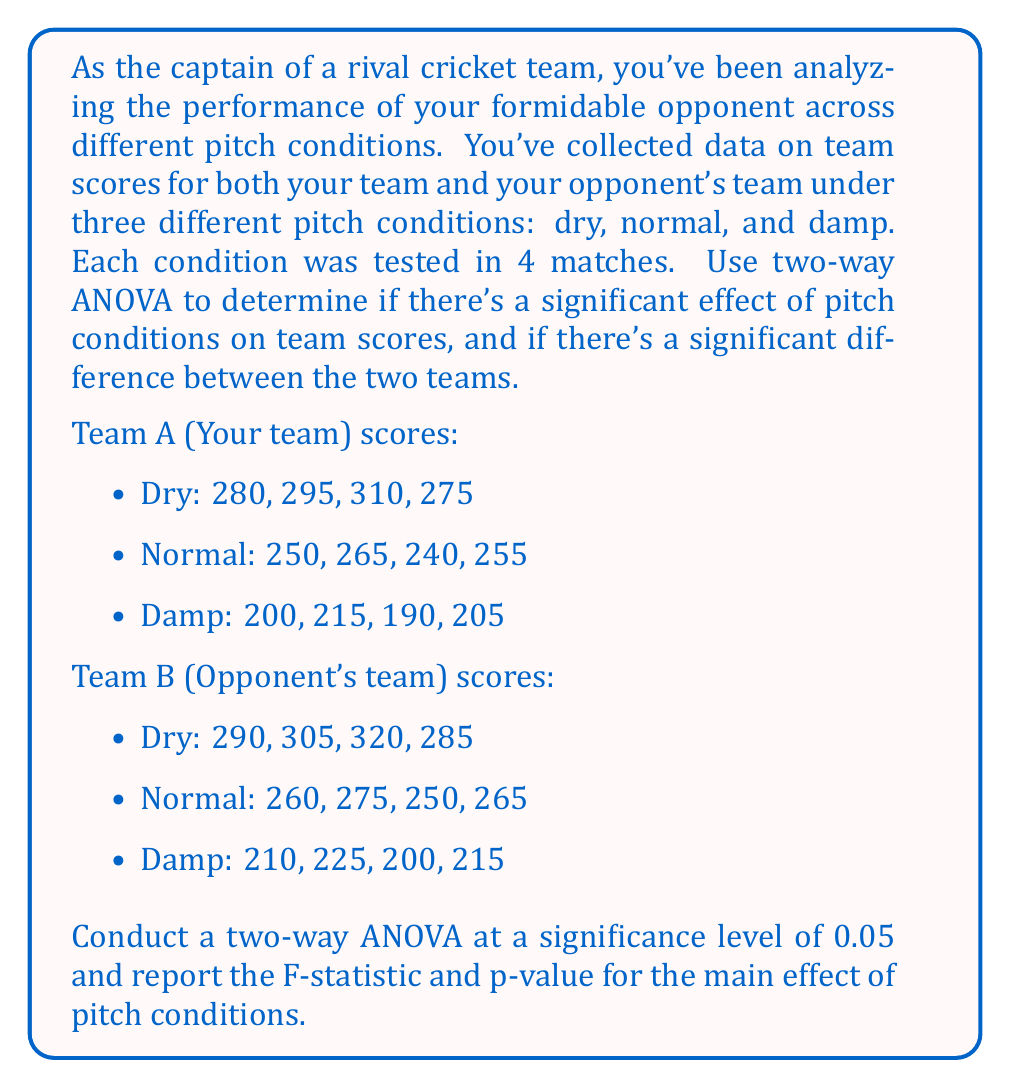Help me with this question. To conduct a two-way ANOVA, we'll follow these steps:

1. Calculate the total sum of squares (SST), sum of squares for pitch conditions (SSA), sum of squares for teams (SSB), sum of squares for interaction (SSAB), and sum of squares for error (SSE).

2. Calculate the degrees of freedom for each source of variation.

3. Calculate the mean squares for each source of variation.

4. Calculate the F-statistics and p-values.

Let's begin:

1. Calculating sums of squares:

SST = $\sum_{i=1}^{a}\sum_{j=1}^{b}\sum_{k=1}^{n} (X_{ijk} - \bar{X})^2$ = 80,775

SSA (pitch conditions) = $bn\sum_{i=1}^{a} (\bar{X_{i..}} - \bar{X})^2$ = 77,700

SSB (teams) = $an\sum_{j=1}^{b} (\bar{X_{.j.}} - \bar{X})^2$ = 600

SSAB (interaction) = $n\sum_{i=1}^{a}\sum_{j=1}^{b} (\bar{X_{ij.}} - \bar{X_{i..}} - \bar{X_{.j.}} + \bar{X})^2$ = 0

SSE (error) = SST - SSA - SSB - SSAB = 2,475

2. Degrees of freedom:

df_A (pitch conditions) = a - 1 = 2
df_B (teams) = b - 1 = 1
df_AB (interaction) = (a - 1)(b - 1) = 2
df_E (error) = ab(n - 1) = 18
df_T (total) = abn - 1 = 23

3. Mean squares:

MSA = SSA / df_A = 77,700 / 2 = 38,850
MSB = SSB / df_B = 600 / 1 = 600
MSAB = SSAB / df_AB = 0 / 2 = 0
MSE = SSE / df_E = 2,475 / 18 = 137.5

4. F-statistics and p-values:

For pitch conditions:
F = MSA / MSE = 38,850 / 137.5 = 282.55

To find the p-value, we use the F-distribution with df_A = 2 and df_E = 18.
p-value = P(F > 282.55) ≈ 1.11 × 10^(-14)
Answer: The F-statistic for the main effect of pitch conditions is 282.55, and the corresponding p-value is approximately 1.11 × 10^(-14). Since the p-value is less than the significance level of 0.05, we conclude that there is a significant effect of pitch conditions on team scores. 